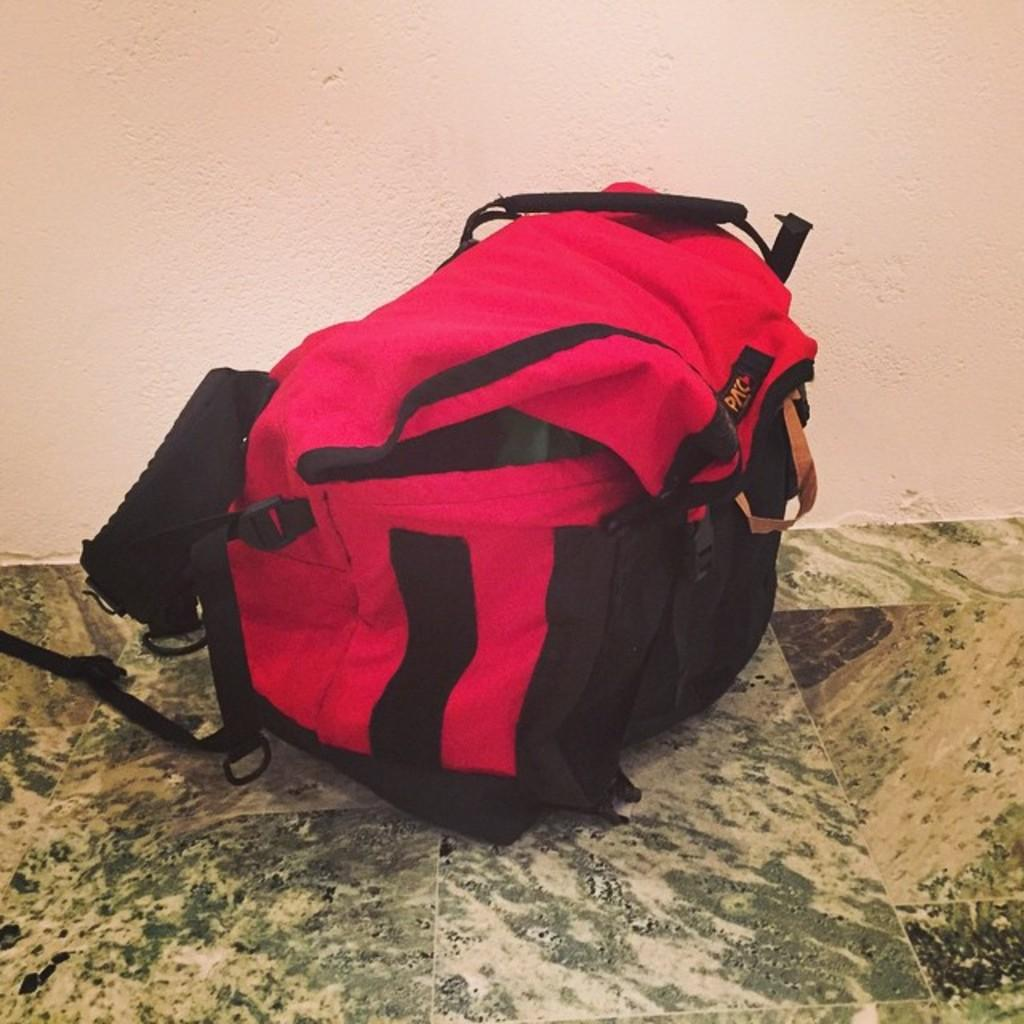What object is on the floor in the image? There is a bag on the floor in the image. How many bubbles are floating around the bag in the image? There are no bubbles present in the image. 